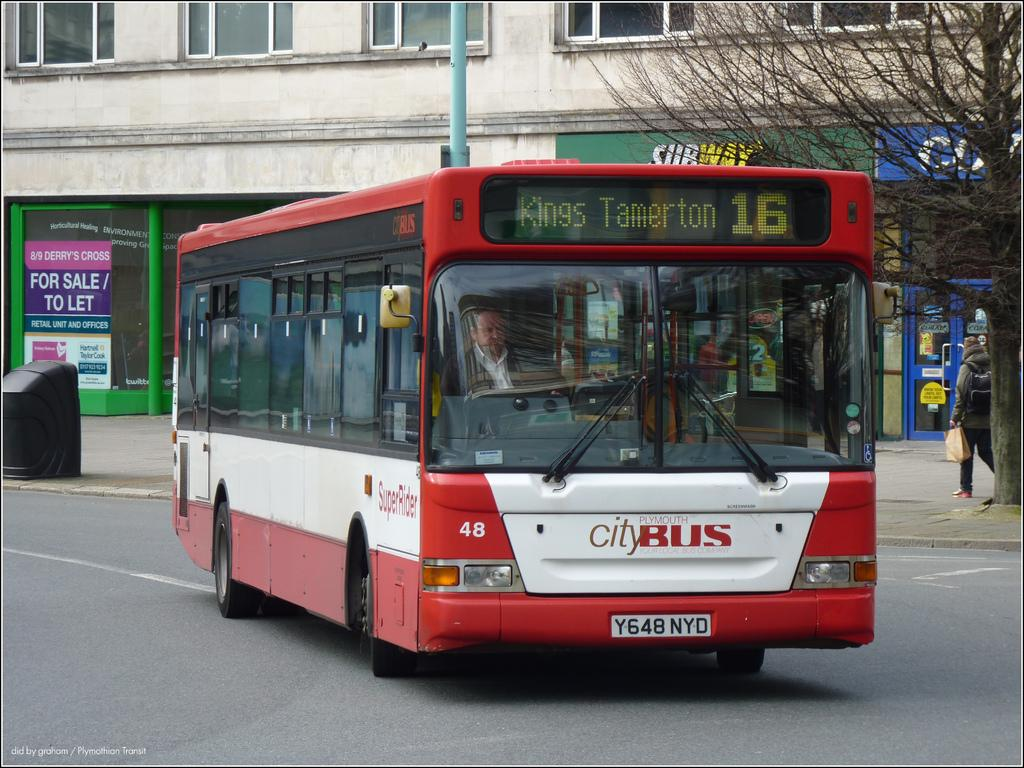<image>
Write a terse but informative summary of the picture. a bus that says city bus on the front 